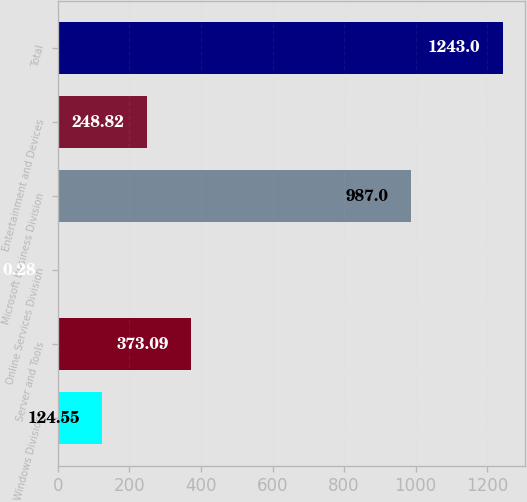Convert chart. <chart><loc_0><loc_0><loc_500><loc_500><bar_chart><fcel>Windows Division<fcel>Server and Tools<fcel>Online Services Division<fcel>Microsoft Business Division<fcel>Entertainment and Devices<fcel>Total<nl><fcel>124.55<fcel>373.09<fcel>0.28<fcel>987<fcel>248.82<fcel>1243<nl></chart> 